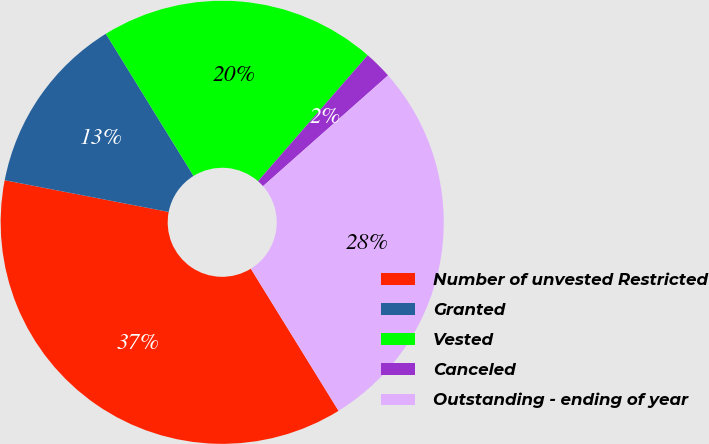Convert chart to OTSL. <chart><loc_0><loc_0><loc_500><loc_500><pie_chart><fcel>Number of unvested Restricted<fcel>Granted<fcel>Vested<fcel>Canceled<fcel>Outstanding - ending of year<nl><fcel>36.84%<fcel>13.16%<fcel>20.2%<fcel>2.06%<fcel>27.73%<nl></chart> 